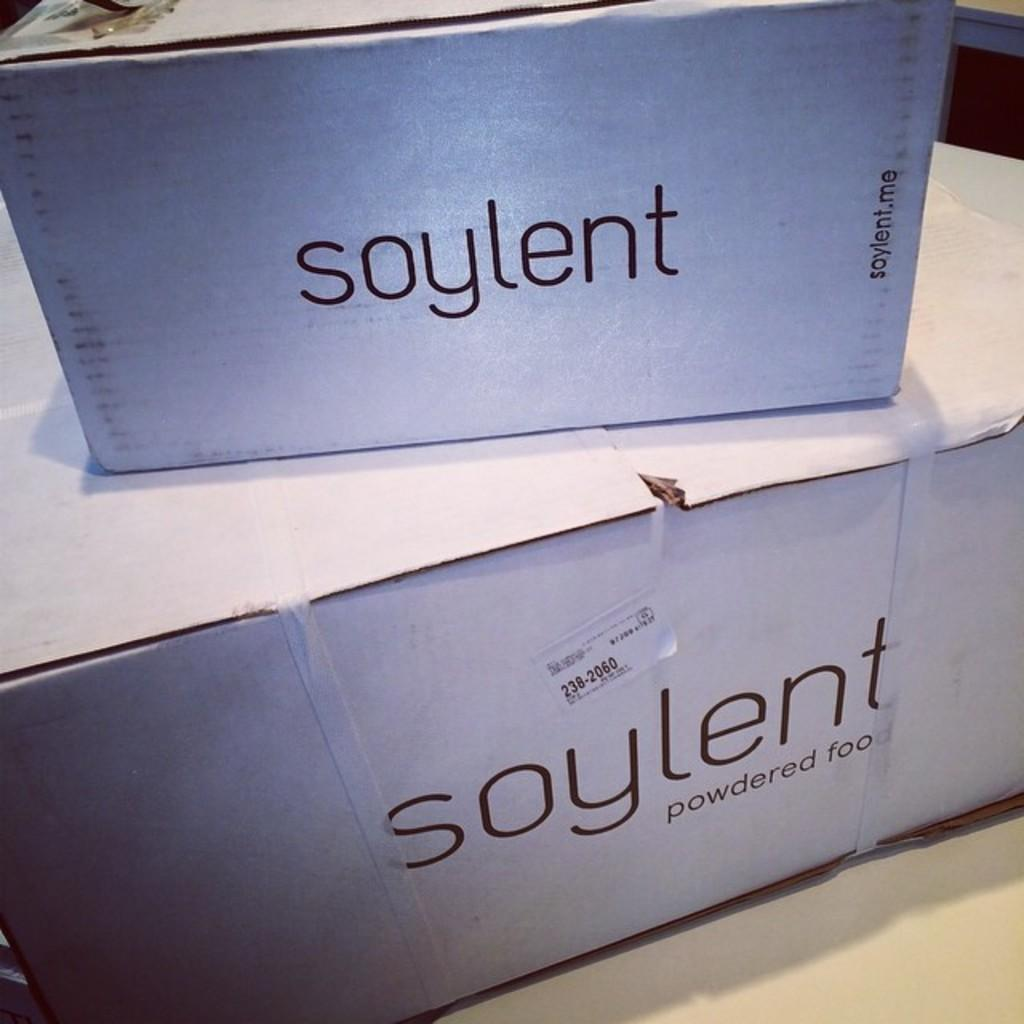<image>
Relay a brief, clear account of the picture shown. two white boxes of Soylent powdered food stacked on each other 